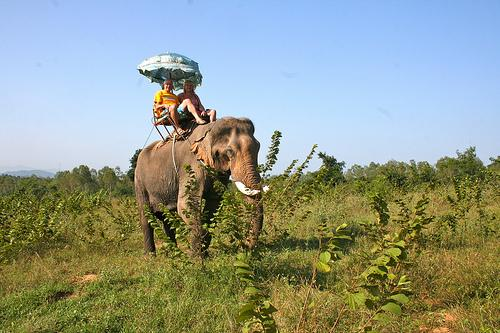Describe the color and type of the umbrella covering the couple. The umbrella is blue with embellishments, shading the couple from the sun. What is the most prominent object in the image and what are its characteristics? The most prominent object is the elephant, which is greyish-brown, has large white tusks, big ears, and is being ridden by two people. State the type of saddle on the elephant and the strap holding it in place. There is a chair saddle for the elephant, with a strap holding it securely on the elephant. Tell me what the couple on the elephant is wearing and how they protect themselves from the sun. The man is wearing a yellow shirt and blue shorts, and the other person is wearing a red and white shirt. They are both under a blue umbrella to protect themselves from the sun. List the elements present in the image. Elephant, couple, tusks, green plants, chair saddle, blue umbrella, green trees, man wearing yellow shirt, sky, grass, shorts, elephant ear, weeds, person wearing red and white shirt, mountains. Identify the type of setting where the elephant is walking and the weather condition. The elephant is walking in a field with green plants and trees, surrounded by a clear cloudless sky, indicating sunny weather. Identify the elements in the image indicating a clear day. The sky is a blue color, and there are no clouds in the sky, indicating a clear day with sunny weather conditions. Describe the foliage and plants present in the image. There are green plants and weeds in the field, with green leaves and brown stems. Green trees can also be seen in the background. 